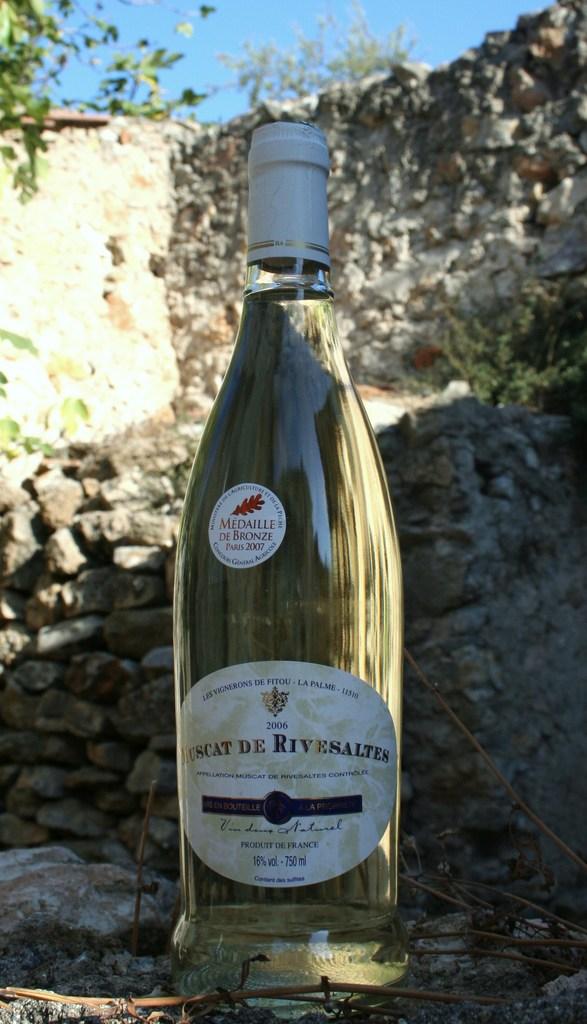What is the alcohol percentage?
Your answer should be very brief. 16. 